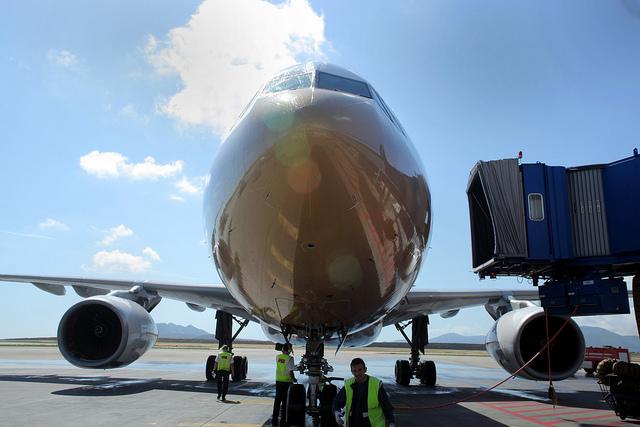Is it safe to load the passengers now?
Keep it brief. No. How many workers are there on the plane?
Keep it brief. 3. How many people are around the plane?
Keep it brief. 3. 